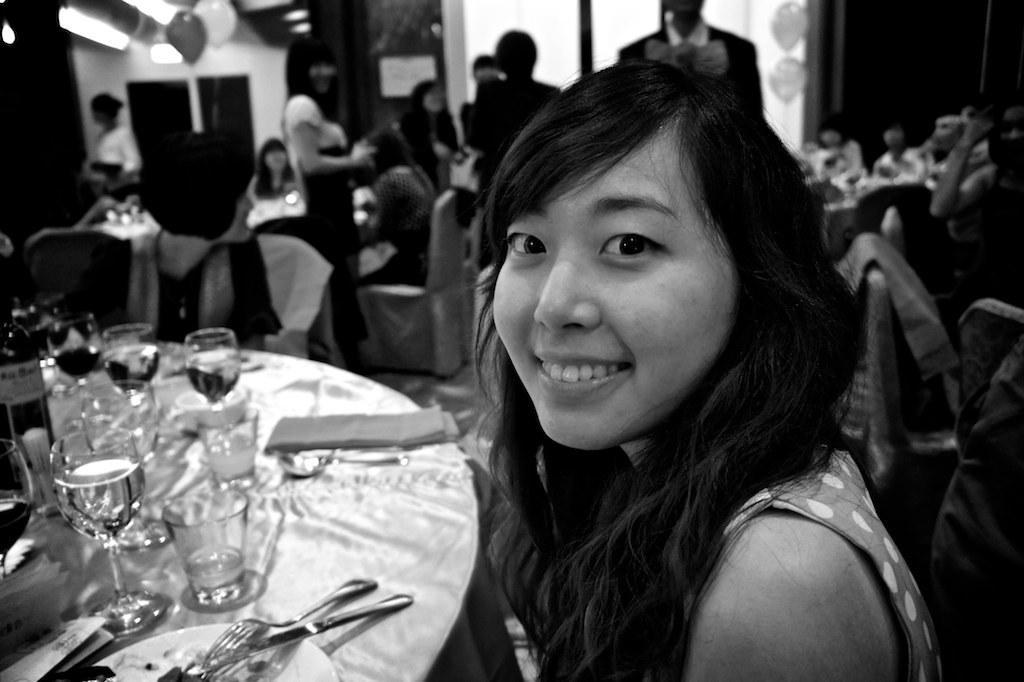Could you give a brief overview of what you see in this image? This is a black and white image. In this image we can see a woman and a table containing some spoons, plates, tissue papers, knives, forks, bottles and a group of glasses placed on it. We can also see some chairs, a group of people, some balloons, lights and a wall. 